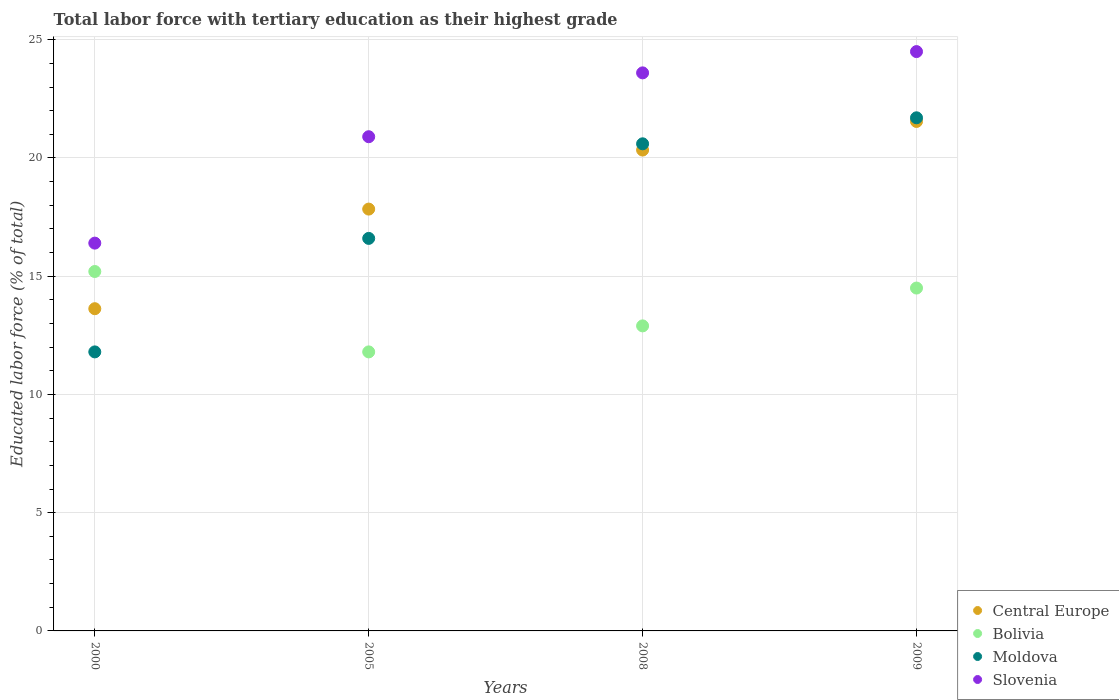Is the number of dotlines equal to the number of legend labels?
Provide a succinct answer. Yes. What is the percentage of male labor force with tertiary education in Slovenia in 2005?
Offer a very short reply. 20.9. Across all years, what is the maximum percentage of male labor force with tertiary education in Bolivia?
Provide a succinct answer. 15.2. Across all years, what is the minimum percentage of male labor force with tertiary education in Bolivia?
Make the answer very short. 11.8. In which year was the percentage of male labor force with tertiary education in Central Europe maximum?
Provide a short and direct response. 2009. In which year was the percentage of male labor force with tertiary education in Central Europe minimum?
Offer a terse response. 2000. What is the total percentage of male labor force with tertiary education in Central Europe in the graph?
Offer a very short reply. 73.35. What is the difference between the percentage of male labor force with tertiary education in Bolivia in 2008 and that in 2009?
Offer a very short reply. -1.6. What is the difference between the percentage of male labor force with tertiary education in Moldova in 2000 and the percentage of male labor force with tertiary education in Slovenia in 2005?
Offer a very short reply. -9.1. What is the average percentage of male labor force with tertiary education in Bolivia per year?
Offer a terse response. 13.6. In the year 2000, what is the difference between the percentage of male labor force with tertiary education in Moldova and percentage of male labor force with tertiary education in Central Europe?
Your answer should be very brief. -1.83. What is the ratio of the percentage of male labor force with tertiary education in Central Europe in 2000 to that in 2005?
Provide a short and direct response. 0.76. Is the percentage of male labor force with tertiary education in Slovenia in 2008 less than that in 2009?
Provide a succinct answer. Yes. What is the difference between the highest and the second highest percentage of male labor force with tertiary education in Bolivia?
Ensure brevity in your answer.  0.7. What is the difference between the highest and the lowest percentage of male labor force with tertiary education in Bolivia?
Your answer should be compact. 3.4. Is it the case that in every year, the sum of the percentage of male labor force with tertiary education in Slovenia and percentage of male labor force with tertiary education in Bolivia  is greater than the sum of percentage of male labor force with tertiary education in Moldova and percentage of male labor force with tertiary education in Central Europe?
Give a very brief answer. Yes. Does the percentage of male labor force with tertiary education in Slovenia monotonically increase over the years?
Ensure brevity in your answer.  Yes. Is the percentage of male labor force with tertiary education in Bolivia strictly greater than the percentage of male labor force with tertiary education in Central Europe over the years?
Keep it short and to the point. No. How many dotlines are there?
Offer a terse response. 4. What is the difference between two consecutive major ticks on the Y-axis?
Offer a terse response. 5. Does the graph contain any zero values?
Keep it short and to the point. No. Does the graph contain grids?
Your response must be concise. Yes. Where does the legend appear in the graph?
Your answer should be compact. Bottom right. How many legend labels are there?
Offer a terse response. 4. How are the legend labels stacked?
Provide a succinct answer. Vertical. What is the title of the graph?
Make the answer very short. Total labor force with tertiary education as their highest grade. What is the label or title of the X-axis?
Ensure brevity in your answer.  Years. What is the label or title of the Y-axis?
Your answer should be compact. Educated labor force (% of total). What is the Educated labor force (% of total) of Central Europe in 2000?
Your answer should be very brief. 13.63. What is the Educated labor force (% of total) in Bolivia in 2000?
Provide a short and direct response. 15.2. What is the Educated labor force (% of total) of Moldova in 2000?
Your response must be concise. 11.8. What is the Educated labor force (% of total) in Slovenia in 2000?
Your response must be concise. 16.4. What is the Educated labor force (% of total) in Central Europe in 2005?
Provide a succinct answer. 17.84. What is the Educated labor force (% of total) in Bolivia in 2005?
Give a very brief answer. 11.8. What is the Educated labor force (% of total) in Moldova in 2005?
Your answer should be very brief. 16.6. What is the Educated labor force (% of total) of Slovenia in 2005?
Provide a succinct answer. 20.9. What is the Educated labor force (% of total) in Central Europe in 2008?
Provide a short and direct response. 20.34. What is the Educated labor force (% of total) of Bolivia in 2008?
Your response must be concise. 12.9. What is the Educated labor force (% of total) in Moldova in 2008?
Offer a terse response. 20.6. What is the Educated labor force (% of total) of Slovenia in 2008?
Provide a short and direct response. 23.6. What is the Educated labor force (% of total) in Central Europe in 2009?
Make the answer very short. 21.55. What is the Educated labor force (% of total) in Bolivia in 2009?
Ensure brevity in your answer.  14.5. What is the Educated labor force (% of total) of Moldova in 2009?
Offer a very short reply. 21.7. What is the Educated labor force (% of total) of Slovenia in 2009?
Your answer should be very brief. 24.5. Across all years, what is the maximum Educated labor force (% of total) of Central Europe?
Ensure brevity in your answer.  21.55. Across all years, what is the maximum Educated labor force (% of total) in Bolivia?
Provide a succinct answer. 15.2. Across all years, what is the maximum Educated labor force (% of total) in Moldova?
Keep it short and to the point. 21.7. Across all years, what is the minimum Educated labor force (% of total) of Central Europe?
Make the answer very short. 13.63. Across all years, what is the minimum Educated labor force (% of total) of Bolivia?
Provide a short and direct response. 11.8. Across all years, what is the minimum Educated labor force (% of total) in Moldova?
Ensure brevity in your answer.  11.8. Across all years, what is the minimum Educated labor force (% of total) in Slovenia?
Your answer should be very brief. 16.4. What is the total Educated labor force (% of total) of Central Europe in the graph?
Give a very brief answer. 73.35. What is the total Educated labor force (% of total) in Bolivia in the graph?
Offer a very short reply. 54.4. What is the total Educated labor force (% of total) in Moldova in the graph?
Your response must be concise. 70.7. What is the total Educated labor force (% of total) of Slovenia in the graph?
Offer a very short reply. 85.4. What is the difference between the Educated labor force (% of total) in Central Europe in 2000 and that in 2005?
Offer a terse response. -4.21. What is the difference between the Educated labor force (% of total) of Slovenia in 2000 and that in 2005?
Provide a short and direct response. -4.5. What is the difference between the Educated labor force (% of total) in Central Europe in 2000 and that in 2008?
Your response must be concise. -6.71. What is the difference between the Educated labor force (% of total) in Central Europe in 2000 and that in 2009?
Offer a terse response. -7.92. What is the difference between the Educated labor force (% of total) of Bolivia in 2000 and that in 2009?
Your response must be concise. 0.7. What is the difference between the Educated labor force (% of total) in Central Europe in 2005 and that in 2008?
Give a very brief answer. -2.5. What is the difference between the Educated labor force (% of total) in Bolivia in 2005 and that in 2008?
Provide a succinct answer. -1.1. What is the difference between the Educated labor force (% of total) in Central Europe in 2005 and that in 2009?
Keep it short and to the point. -3.71. What is the difference between the Educated labor force (% of total) in Moldova in 2005 and that in 2009?
Provide a succinct answer. -5.1. What is the difference between the Educated labor force (% of total) of Slovenia in 2005 and that in 2009?
Provide a succinct answer. -3.6. What is the difference between the Educated labor force (% of total) of Central Europe in 2008 and that in 2009?
Your answer should be compact. -1.21. What is the difference between the Educated labor force (% of total) in Bolivia in 2008 and that in 2009?
Keep it short and to the point. -1.6. What is the difference between the Educated labor force (% of total) of Slovenia in 2008 and that in 2009?
Your answer should be compact. -0.9. What is the difference between the Educated labor force (% of total) of Central Europe in 2000 and the Educated labor force (% of total) of Bolivia in 2005?
Keep it short and to the point. 1.83. What is the difference between the Educated labor force (% of total) in Central Europe in 2000 and the Educated labor force (% of total) in Moldova in 2005?
Ensure brevity in your answer.  -2.97. What is the difference between the Educated labor force (% of total) of Central Europe in 2000 and the Educated labor force (% of total) of Slovenia in 2005?
Your answer should be very brief. -7.27. What is the difference between the Educated labor force (% of total) of Bolivia in 2000 and the Educated labor force (% of total) of Slovenia in 2005?
Ensure brevity in your answer.  -5.7. What is the difference between the Educated labor force (% of total) of Moldova in 2000 and the Educated labor force (% of total) of Slovenia in 2005?
Offer a very short reply. -9.1. What is the difference between the Educated labor force (% of total) of Central Europe in 2000 and the Educated labor force (% of total) of Bolivia in 2008?
Your answer should be compact. 0.73. What is the difference between the Educated labor force (% of total) in Central Europe in 2000 and the Educated labor force (% of total) in Moldova in 2008?
Your answer should be very brief. -6.97. What is the difference between the Educated labor force (% of total) of Central Europe in 2000 and the Educated labor force (% of total) of Slovenia in 2008?
Your answer should be compact. -9.97. What is the difference between the Educated labor force (% of total) in Bolivia in 2000 and the Educated labor force (% of total) in Slovenia in 2008?
Your response must be concise. -8.4. What is the difference between the Educated labor force (% of total) of Central Europe in 2000 and the Educated labor force (% of total) of Bolivia in 2009?
Your answer should be compact. -0.87. What is the difference between the Educated labor force (% of total) in Central Europe in 2000 and the Educated labor force (% of total) in Moldova in 2009?
Offer a terse response. -8.07. What is the difference between the Educated labor force (% of total) in Central Europe in 2000 and the Educated labor force (% of total) in Slovenia in 2009?
Offer a terse response. -10.87. What is the difference between the Educated labor force (% of total) in Bolivia in 2000 and the Educated labor force (% of total) in Moldova in 2009?
Your response must be concise. -6.5. What is the difference between the Educated labor force (% of total) in Bolivia in 2000 and the Educated labor force (% of total) in Slovenia in 2009?
Provide a succinct answer. -9.3. What is the difference between the Educated labor force (% of total) of Moldova in 2000 and the Educated labor force (% of total) of Slovenia in 2009?
Give a very brief answer. -12.7. What is the difference between the Educated labor force (% of total) of Central Europe in 2005 and the Educated labor force (% of total) of Bolivia in 2008?
Your response must be concise. 4.94. What is the difference between the Educated labor force (% of total) in Central Europe in 2005 and the Educated labor force (% of total) in Moldova in 2008?
Keep it short and to the point. -2.76. What is the difference between the Educated labor force (% of total) of Central Europe in 2005 and the Educated labor force (% of total) of Slovenia in 2008?
Keep it short and to the point. -5.76. What is the difference between the Educated labor force (% of total) of Bolivia in 2005 and the Educated labor force (% of total) of Moldova in 2008?
Your answer should be very brief. -8.8. What is the difference between the Educated labor force (% of total) in Moldova in 2005 and the Educated labor force (% of total) in Slovenia in 2008?
Make the answer very short. -7. What is the difference between the Educated labor force (% of total) in Central Europe in 2005 and the Educated labor force (% of total) in Bolivia in 2009?
Give a very brief answer. 3.34. What is the difference between the Educated labor force (% of total) of Central Europe in 2005 and the Educated labor force (% of total) of Moldova in 2009?
Your response must be concise. -3.86. What is the difference between the Educated labor force (% of total) of Central Europe in 2005 and the Educated labor force (% of total) of Slovenia in 2009?
Give a very brief answer. -6.66. What is the difference between the Educated labor force (% of total) in Bolivia in 2005 and the Educated labor force (% of total) in Moldova in 2009?
Ensure brevity in your answer.  -9.9. What is the difference between the Educated labor force (% of total) in Bolivia in 2005 and the Educated labor force (% of total) in Slovenia in 2009?
Provide a succinct answer. -12.7. What is the difference between the Educated labor force (% of total) in Central Europe in 2008 and the Educated labor force (% of total) in Bolivia in 2009?
Keep it short and to the point. 5.84. What is the difference between the Educated labor force (% of total) in Central Europe in 2008 and the Educated labor force (% of total) in Moldova in 2009?
Provide a succinct answer. -1.36. What is the difference between the Educated labor force (% of total) in Central Europe in 2008 and the Educated labor force (% of total) in Slovenia in 2009?
Ensure brevity in your answer.  -4.16. What is the difference between the Educated labor force (% of total) in Bolivia in 2008 and the Educated labor force (% of total) in Slovenia in 2009?
Keep it short and to the point. -11.6. What is the average Educated labor force (% of total) in Central Europe per year?
Provide a succinct answer. 18.34. What is the average Educated labor force (% of total) of Bolivia per year?
Your answer should be very brief. 13.6. What is the average Educated labor force (% of total) in Moldova per year?
Offer a terse response. 17.68. What is the average Educated labor force (% of total) of Slovenia per year?
Make the answer very short. 21.35. In the year 2000, what is the difference between the Educated labor force (% of total) of Central Europe and Educated labor force (% of total) of Bolivia?
Provide a short and direct response. -1.57. In the year 2000, what is the difference between the Educated labor force (% of total) in Central Europe and Educated labor force (% of total) in Moldova?
Your response must be concise. 1.83. In the year 2000, what is the difference between the Educated labor force (% of total) of Central Europe and Educated labor force (% of total) of Slovenia?
Keep it short and to the point. -2.77. In the year 2000, what is the difference between the Educated labor force (% of total) of Bolivia and Educated labor force (% of total) of Slovenia?
Ensure brevity in your answer.  -1.2. In the year 2005, what is the difference between the Educated labor force (% of total) in Central Europe and Educated labor force (% of total) in Bolivia?
Provide a short and direct response. 6.04. In the year 2005, what is the difference between the Educated labor force (% of total) in Central Europe and Educated labor force (% of total) in Moldova?
Offer a terse response. 1.24. In the year 2005, what is the difference between the Educated labor force (% of total) in Central Europe and Educated labor force (% of total) in Slovenia?
Ensure brevity in your answer.  -3.06. In the year 2005, what is the difference between the Educated labor force (% of total) in Bolivia and Educated labor force (% of total) in Moldova?
Your response must be concise. -4.8. In the year 2008, what is the difference between the Educated labor force (% of total) of Central Europe and Educated labor force (% of total) of Bolivia?
Your answer should be very brief. 7.44. In the year 2008, what is the difference between the Educated labor force (% of total) of Central Europe and Educated labor force (% of total) of Moldova?
Your answer should be compact. -0.26. In the year 2008, what is the difference between the Educated labor force (% of total) in Central Europe and Educated labor force (% of total) in Slovenia?
Your answer should be very brief. -3.26. In the year 2008, what is the difference between the Educated labor force (% of total) of Moldova and Educated labor force (% of total) of Slovenia?
Offer a very short reply. -3. In the year 2009, what is the difference between the Educated labor force (% of total) in Central Europe and Educated labor force (% of total) in Bolivia?
Provide a short and direct response. 7.05. In the year 2009, what is the difference between the Educated labor force (% of total) in Central Europe and Educated labor force (% of total) in Moldova?
Provide a succinct answer. -0.15. In the year 2009, what is the difference between the Educated labor force (% of total) of Central Europe and Educated labor force (% of total) of Slovenia?
Give a very brief answer. -2.95. In the year 2009, what is the difference between the Educated labor force (% of total) of Bolivia and Educated labor force (% of total) of Moldova?
Your answer should be compact. -7.2. In the year 2009, what is the difference between the Educated labor force (% of total) in Bolivia and Educated labor force (% of total) in Slovenia?
Ensure brevity in your answer.  -10. In the year 2009, what is the difference between the Educated labor force (% of total) in Moldova and Educated labor force (% of total) in Slovenia?
Ensure brevity in your answer.  -2.8. What is the ratio of the Educated labor force (% of total) of Central Europe in 2000 to that in 2005?
Ensure brevity in your answer.  0.76. What is the ratio of the Educated labor force (% of total) of Bolivia in 2000 to that in 2005?
Make the answer very short. 1.29. What is the ratio of the Educated labor force (% of total) in Moldova in 2000 to that in 2005?
Your answer should be very brief. 0.71. What is the ratio of the Educated labor force (% of total) of Slovenia in 2000 to that in 2005?
Make the answer very short. 0.78. What is the ratio of the Educated labor force (% of total) in Central Europe in 2000 to that in 2008?
Give a very brief answer. 0.67. What is the ratio of the Educated labor force (% of total) of Bolivia in 2000 to that in 2008?
Your response must be concise. 1.18. What is the ratio of the Educated labor force (% of total) in Moldova in 2000 to that in 2008?
Offer a very short reply. 0.57. What is the ratio of the Educated labor force (% of total) of Slovenia in 2000 to that in 2008?
Offer a very short reply. 0.69. What is the ratio of the Educated labor force (% of total) of Central Europe in 2000 to that in 2009?
Offer a very short reply. 0.63. What is the ratio of the Educated labor force (% of total) of Bolivia in 2000 to that in 2009?
Provide a short and direct response. 1.05. What is the ratio of the Educated labor force (% of total) in Moldova in 2000 to that in 2009?
Your answer should be compact. 0.54. What is the ratio of the Educated labor force (% of total) in Slovenia in 2000 to that in 2009?
Ensure brevity in your answer.  0.67. What is the ratio of the Educated labor force (% of total) in Central Europe in 2005 to that in 2008?
Your answer should be compact. 0.88. What is the ratio of the Educated labor force (% of total) in Bolivia in 2005 to that in 2008?
Your answer should be compact. 0.91. What is the ratio of the Educated labor force (% of total) in Moldova in 2005 to that in 2008?
Give a very brief answer. 0.81. What is the ratio of the Educated labor force (% of total) of Slovenia in 2005 to that in 2008?
Give a very brief answer. 0.89. What is the ratio of the Educated labor force (% of total) in Central Europe in 2005 to that in 2009?
Make the answer very short. 0.83. What is the ratio of the Educated labor force (% of total) in Bolivia in 2005 to that in 2009?
Your answer should be compact. 0.81. What is the ratio of the Educated labor force (% of total) of Moldova in 2005 to that in 2009?
Make the answer very short. 0.77. What is the ratio of the Educated labor force (% of total) of Slovenia in 2005 to that in 2009?
Offer a very short reply. 0.85. What is the ratio of the Educated labor force (% of total) of Central Europe in 2008 to that in 2009?
Ensure brevity in your answer.  0.94. What is the ratio of the Educated labor force (% of total) of Bolivia in 2008 to that in 2009?
Give a very brief answer. 0.89. What is the ratio of the Educated labor force (% of total) of Moldova in 2008 to that in 2009?
Give a very brief answer. 0.95. What is the ratio of the Educated labor force (% of total) in Slovenia in 2008 to that in 2009?
Your response must be concise. 0.96. What is the difference between the highest and the second highest Educated labor force (% of total) in Central Europe?
Offer a very short reply. 1.21. What is the difference between the highest and the second highest Educated labor force (% of total) in Slovenia?
Provide a short and direct response. 0.9. What is the difference between the highest and the lowest Educated labor force (% of total) of Central Europe?
Offer a very short reply. 7.92. What is the difference between the highest and the lowest Educated labor force (% of total) of Moldova?
Make the answer very short. 9.9. 